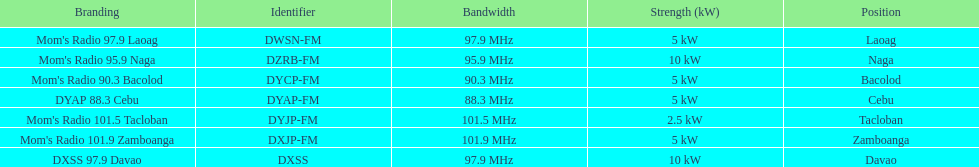Which of these stations broadcasts with the least power? Mom's Radio 101.5 Tacloban. 